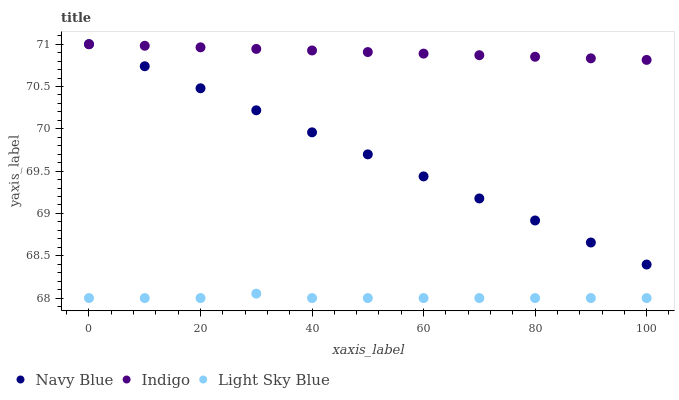Does Light Sky Blue have the minimum area under the curve?
Answer yes or no. Yes. Does Indigo have the maximum area under the curve?
Answer yes or no. Yes. Does Indigo have the minimum area under the curve?
Answer yes or no. No. Does Light Sky Blue have the maximum area under the curve?
Answer yes or no. No. Is Navy Blue the smoothest?
Answer yes or no. Yes. Is Light Sky Blue the roughest?
Answer yes or no. Yes. Is Indigo the smoothest?
Answer yes or no. No. Is Indigo the roughest?
Answer yes or no. No. Does Light Sky Blue have the lowest value?
Answer yes or no. Yes. Does Indigo have the lowest value?
Answer yes or no. No. Does Indigo have the highest value?
Answer yes or no. Yes. Does Light Sky Blue have the highest value?
Answer yes or no. No. Is Light Sky Blue less than Navy Blue?
Answer yes or no. Yes. Is Indigo greater than Light Sky Blue?
Answer yes or no. Yes. Does Navy Blue intersect Indigo?
Answer yes or no. Yes. Is Navy Blue less than Indigo?
Answer yes or no. No. Is Navy Blue greater than Indigo?
Answer yes or no. No. Does Light Sky Blue intersect Navy Blue?
Answer yes or no. No. 